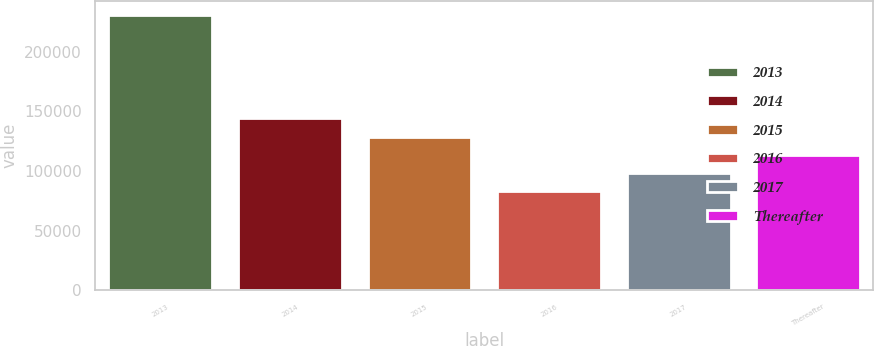<chart> <loc_0><loc_0><loc_500><loc_500><bar_chart><fcel>2013<fcel>2014<fcel>2015<fcel>2016<fcel>2017<fcel>Thereafter<nl><fcel>231137<fcel>144288<fcel>128805<fcel>83603<fcel>98356.4<fcel>113110<nl></chart> 